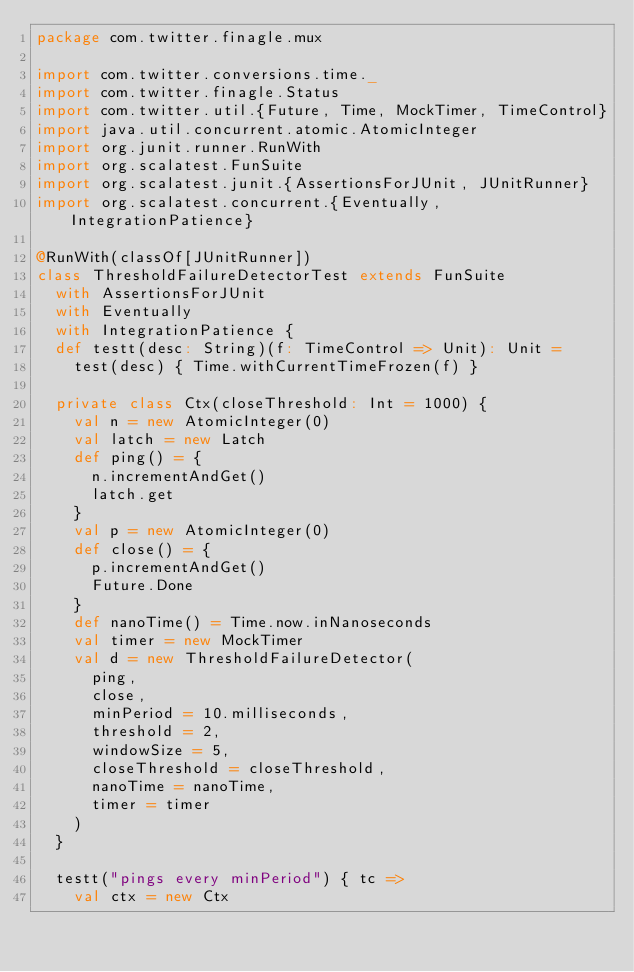Convert code to text. <code><loc_0><loc_0><loc_500><loc_500><_Scala_>package com.twitter.finagle.mux

import com.twitter.conversions.time._
import com.twitter.finagle.Status
import com.twitter.util.{Future, Time, MockTimer, TimeControl}
import java.util.concurrent.atomic.AtomicInteger
import org.junit.runner.RunWith
import org.scalatest.FunSuite
import org.scalatest.junit.{AssertionsForJUnit, JUnitRunner}
import org.scalatest.concurrent.{Eventually, IntegrationPatience}

@RunWith(classOf[JUnitRunner])
class ThresholdFailureDetectorTest extends FunSuite
  with AssertionsForJUnit
  with Eventually
  with IntegrationPatience {
  def testt(desc: String)(f: TimeControl => Unit): Unit =
    test(desc) { Time.withCurrentTimeFrozen(f) }

  private class Ctx(closeThreshold: Int = 1000) {
    val n = new AtomicInteger(0)
    val latch = new Latch
    def ping() = {
      n.incrementAndGet()
      latch.get
    }
    val p = new AtomicInteger(0)
    def close() = {
      p.incrementAndGet()
      Future.Done
    }
    def nanoTime() = Time.now.inNanoseconds
    val timer = new MockTimer
    val d = new ThresholdFailureDetector(
      ping,
      close,
      minPeriod = 10.milliseconds,
      threshold = 2,
      windowSize = 5,
      closeThreshold = closeThreshold,
      nanoTime = nanoTime,
      timer = timer
    )
  }

  testt("pings every minPeriod") { tc =>
    val ctx = new Ctx</code> 